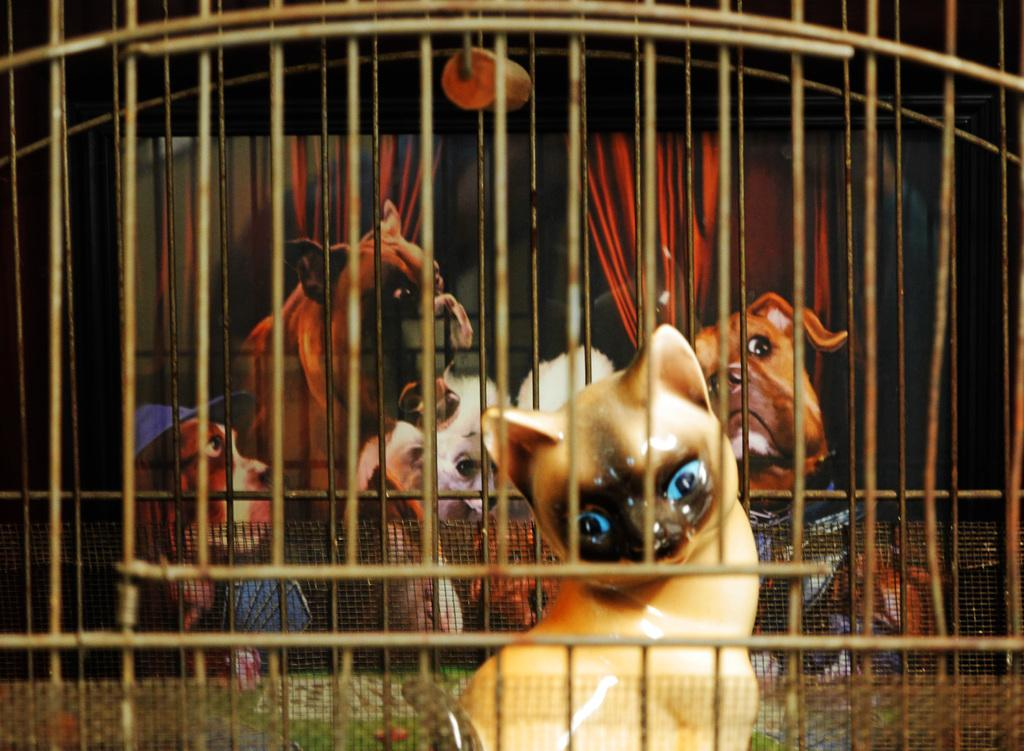What type of enclosure is present in the image? There is a cage in the image. What material is used to create the cage? The cage is made of mesh. What object can be found inside the cage? There is a toy in the cage. What other item is present in the image? There is a photo frame in the image. What can be seen in the photo frame? Animals are visible in the photo frame. What type of society is depicted in the image? There is no depiction of a society in the image; it features a cage, mesh, a toy, a photo frame, and animals in the photo frame. 